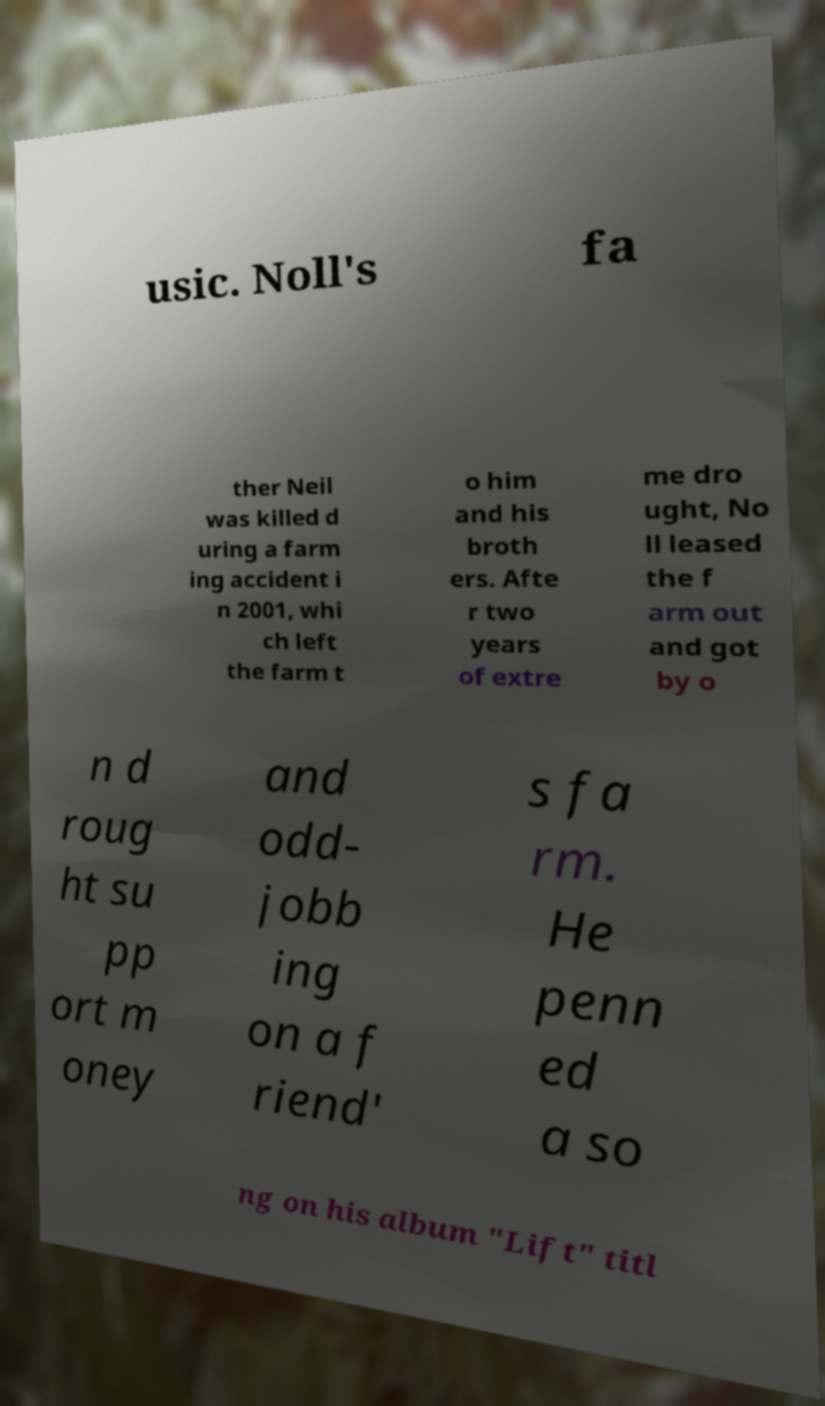Can you accurately transcribe the text from the provided image for me? usic. Noll's fa ther Neil was killed d uring a farm ing accident i n 2001, whi ch left the farm t o him and his broth ers. Afte r two years of extre me dro ught, No ll leased the f arm out and got by o n d roug ht su pp ort m oney and odd- jobb ing on a f riend' s fa rm. He penn ed a so ng on his album "Lift" titl 